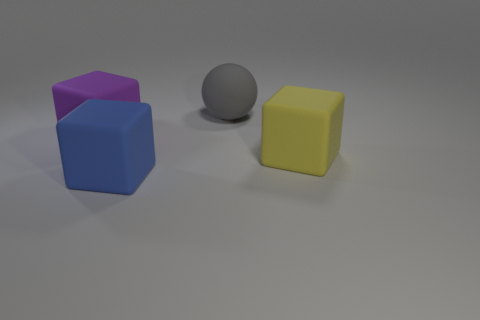Add 2 yellow rubber things. How many objects exist? 6 Subtract all cubes. How many objects are left? 1 Subtract 1 purple blocks. How many objects are left? 3 Subtract all small brown objects. Subtract all yellow rubber objects. How many objects are left? 3 Add 2 big gray objects. How many big gray objects are left? 3 Add 2 large blue rubber cubes. How many large blue rubber cubes exist? 3 